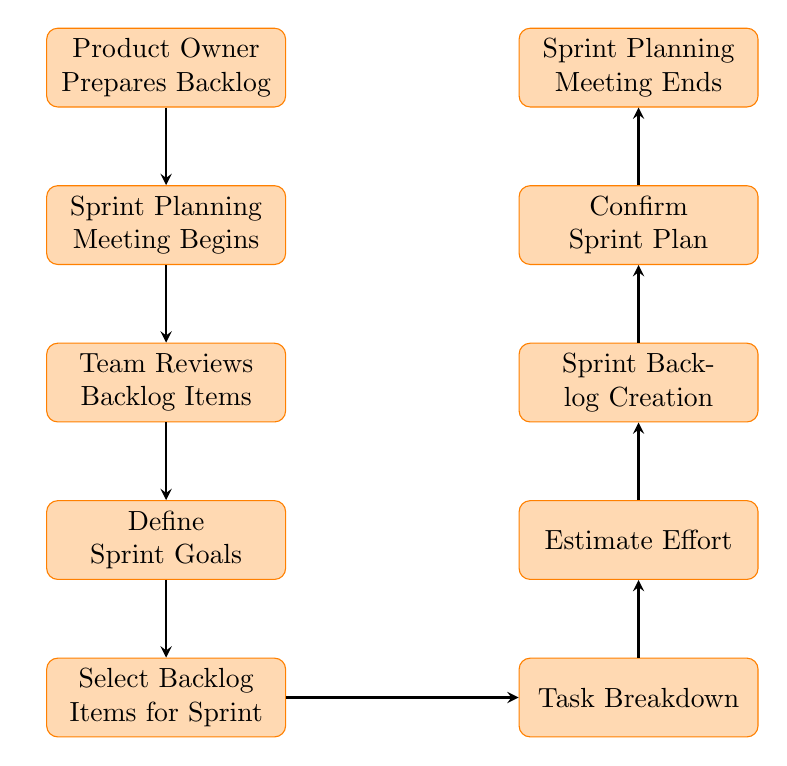What is the first step in the workflow? According to the flow chart, the first step is "Product Owner Prepares Backlog," which is indicated at the top of the diagram as the entry point into the workflow.
Answer: Product Owner Prepares Backlog What is the last step of the Sprint Planning Meeting Workflow? The last step, as seen at the bottom of the diagram, is "Sprint Planning Meeting Ends," marking the conclusion of the workflow.
Answer: Sprint Planning Meeting Ends How many nodes are in this diagram? Counting all the unique steps listed in the flow chart, there are ten nodes representing different stages of the sprint planning meeting workflow.
Answer: Ten What do the nodes between "Select Backlog Items for Sprint" and "Task Breakdown" indicate? The diagram shows that "Select Backlog Items for Sprint" leads to "Task Breakdown," which implicates that after the team selects the items, they move on to break them down into tasks as part of the process.
Answer: Task Breakdown Which role initiates the sprint planning meeting? The initiating role is the Scrum Master, as indicated by the label in the second step of the flow chart.
Answer: Scrum Master What is the purpose of the "Estimate Effort" node? The "Estimate Effort" node refers to the step where the team estimates the required effort for each task, demonstrating evaluation and planning within the workflow.
Answer: Estimate Effort What are the two nodes that have tasks associated with the sprint backlog? The two nodes associated with the sprint backlog are "Sprint Backlog Creation" and "Confirm Sprint Plan," indicating the creation and finalization processes of the sprint backlog.
Answer: Sprint Backlog Creation, Confirm Sprint Plan Which node directly follows "Define Sprint Goals"? The node directly following "Define Sprint Goals" in the diagram is "Select Backlog Items for Sprint," showing the subsequent action taken after goal definition.
Answer: Select Backlog Items for Sprint How do the nodes reflect project decision-making? The nodes demonstrate project decision-making at various stages, particularly in "Define Sprint Goals," "Select Backlog Items for Sprint," and "Confirm Sprint Plan," where the team collaborates to shape direction and commitments for the sprint.
Answer: Collaborative decision-making 